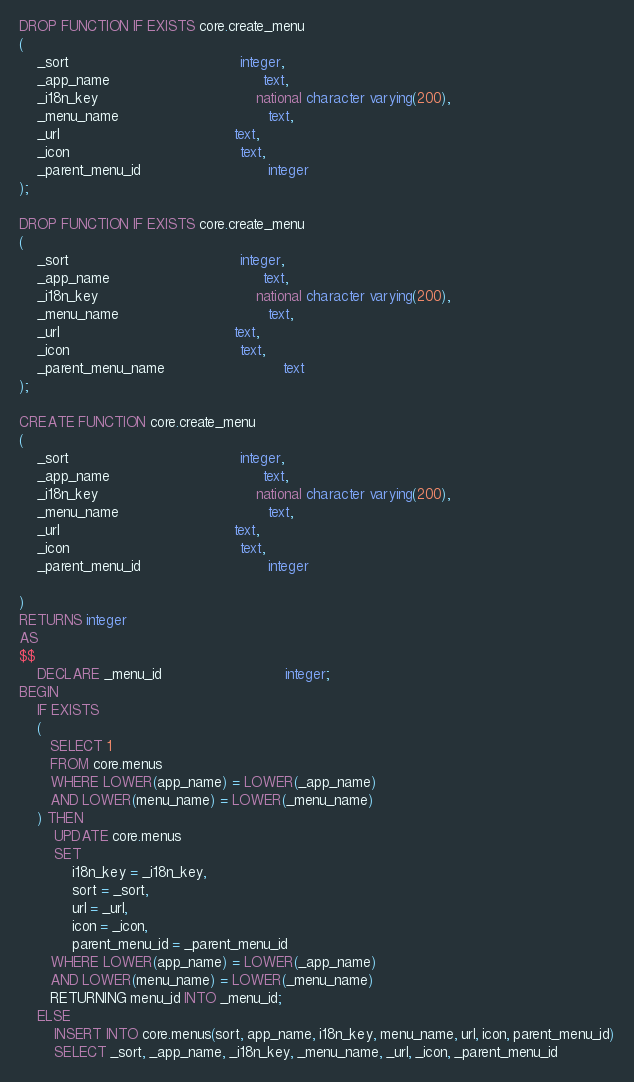<code> <loc_0><loc_0><loc_500><loc_500><_SQL_>DROP FUNCTION IF EXISTS core.create_menu
(
    _sort                                       integer,
    _app_name                                   text,
	_i18n_key									national character varying(200),
    _menu_name                                  text,
    _url                                        text,
    _icon                                       text,
    _parent_menu_id                             integer    
);

DROP FUNCTION IF EXISTS core.create_menu
(
    _sort                                       integer,
    _app_name                                   text,
	_i18n_key									national character varying(200),
    _menu_name                                  text,
    _url                                        text,
    _icon                                       text,
    _parent_menu_name                           text
);

CREATE FUNCTION core.create_menu
(
    _sort                                       integer,
    _app_name                                   text,
	_i18n_key									national character varying(200),
    _menu_name                                  text,
    _url                                        text,
    _icon                                       text,
    _parent_menu_id                             integer
    
)
RETURNS integer
AS
$$
    DECLARE _menu_id                            integer;
BEGIN
    IF EXISTS
    (
       SELECT 1
       FROM core.menus
       WHERE LOWER(app_name) = LOWER(_app_name)
       AND LOWER(menu_name) = LOWER(_menu_name)
    ) THEN
        UPDATE core.menus
        SET
			i18n_key = _i18n_key,
            sort = _sort,
            url = _url,
            icon = _icon,
            parent_menu_id = _parent_menu_id
       WHERE LOWER(app_name) = LOWER(_app_name)
       AND LOWER(menu_name) = LOWER(_menu_name)
       RETURNING menu_id INTO _menu_id;        
    ELSE
        INSERT INTO core.menus(sort, app_name, i18n_key, menu_name, url, icon, parent_menu_id)
        SELECT _sort, _app_name, _i18n_key, _menu_name, _url, _icon, _parent_menu_id</code> 